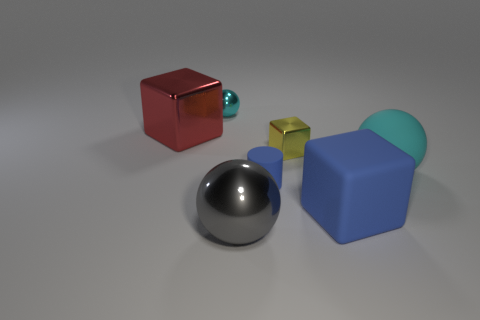Is the color of the small matte thing the same as the big matte block?
Offer a very short reply. Yes. Are there any other things that are the same shape as the tiny blue rubber thing?
Provide a succinct answer. No. There is a tiny cylinder that is the same color as the rubber block; what is its material?
Keep it short and to the point. Rubber. What number of objects are cyan balls to the right of the blue rubber cylinder or cubes to the right of the large gray metal sphere?
Give a very brief answer. 3. Do the red metallic block and the cyan shiny ball have the same size?
Offer a very short reply. No. What number of cubes are either big green metallic things or tiny blue rubber things?
Your answer should be compact. 0. How many things are both behind the large metallic sphere and to the left of the tiny rubber cylinder?
Provide a short and direct response. 2. Does the gray metallic sphere have the same size as the cyan ball to the right of the gray ball?
Give a very brief answer. Yes. There is a blue matte object that is right of the metal cube that is to the right of the small ball; is there a large gray object that is behind it?
Ensure brevity in your answer.  No. The cyan ball that is to the right of the cyan ball that is to the left of the large gray object is made of what material?
Provide a short and direct response. Rubber. 